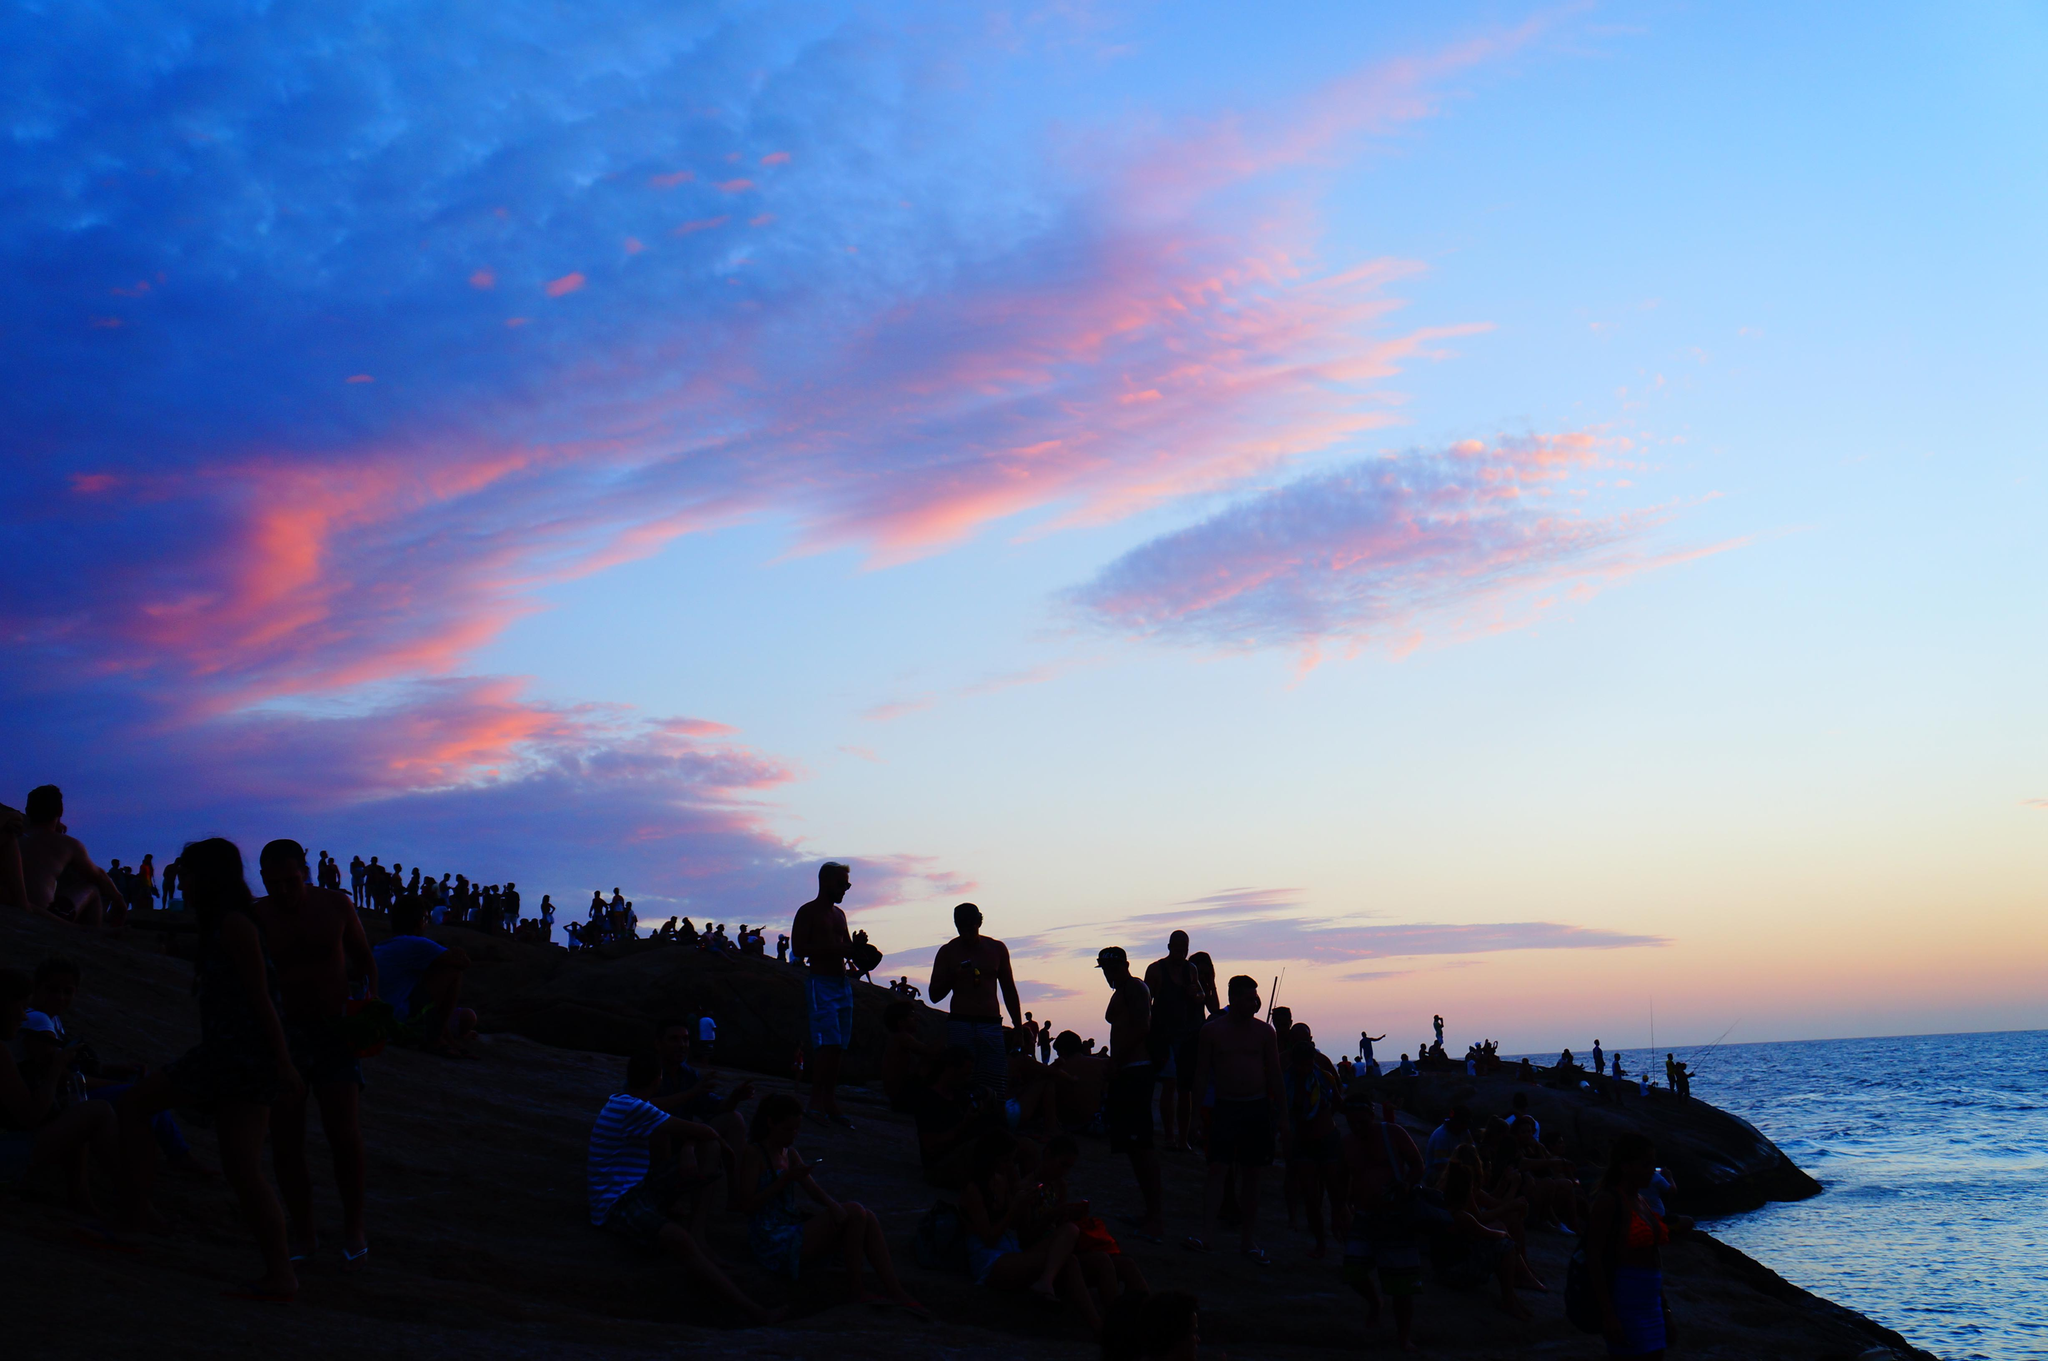What time of day is depicted in the image? The image was taken during sunset. What can be seen on the right side of the image? There is water on the right side of the image. What is on the left side of the image? There is land on the left side of the image. What is happening on the land in the image? There are people standing on the land. How does the anger of the friend affect the work in the image? There is no mention of anger, friend, or work in the image. The image depicts a sunset scene with water, land, and people standing on the land. 